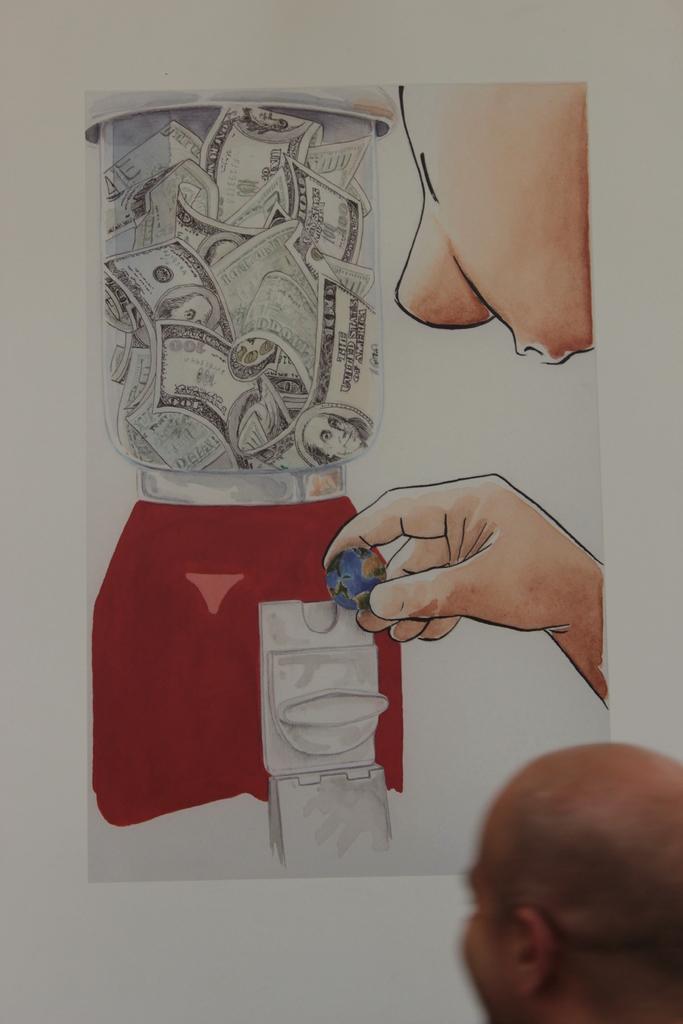In one or two sentences, can you explain what this image depicts? In this picture we can see a person's head and in the background we can see a poster on the wall. 